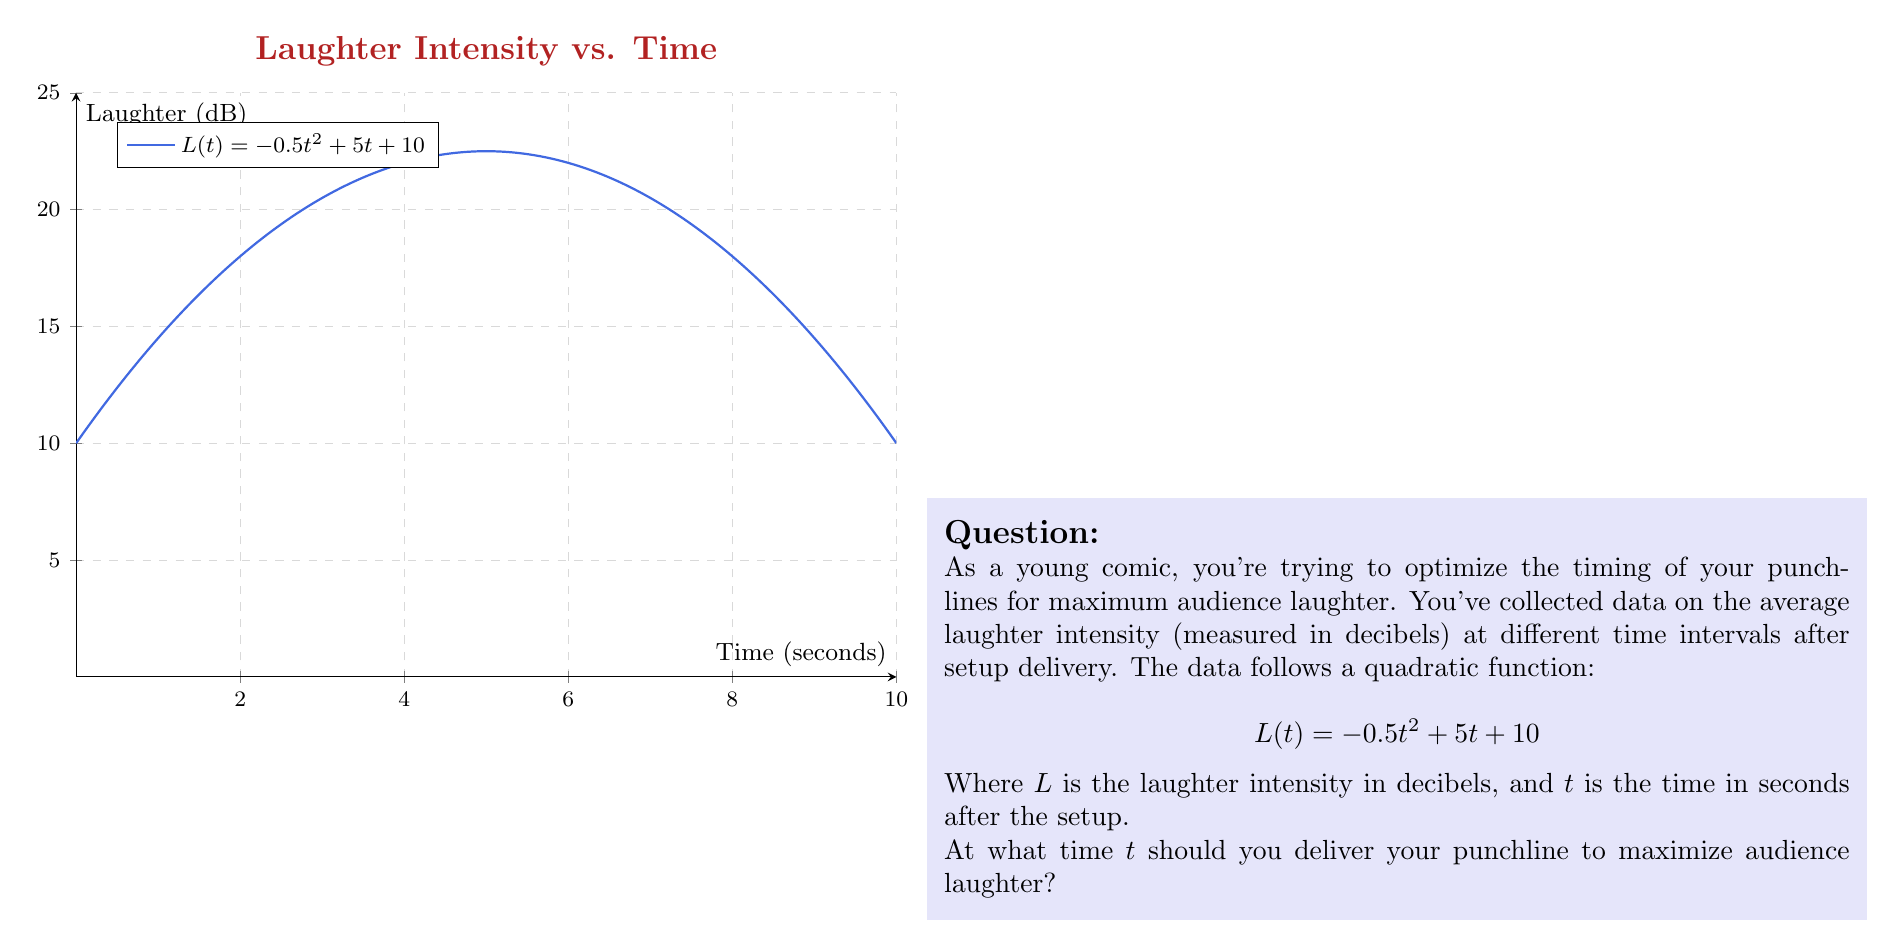Can you answer this question? To find the optimal time for delivering the punchline, we need to find the maximum point of the quadratic function $L(t) = -0.5t^2 + 5t + 10$. This can be done using the following steps:

1) The maximum point of a quadratic function occurs at the vertex of the parabola. For a quadratic function in the form $f(x) = ax^2 + bx + c$, the x-coordinate of the vertex is given by $x = -\frac{b}{2a}$.

2) In our case, $a = -0.5$, $b = 5$, and $c = 10$. Let's substitute these values:

   $$t = -\frac{5}{2(-0.5)} = -\frac{5}{-1} = 5$$

3) To verify this is indeed a maximum (not a minimum), we can check that $a < 0$, which it is ($-0.5 < 0$).

4) Therefore, the laughter intensity is maximized when $t = 5$ seconds.

5) We can calculate the maximum laughter intensity by substituting $t = 5$ into the original function:

   $$L(5) = -0.5(5)^2 + 5(5) + 10 = -12.5 + 25 + 10 = 22.5$$

So, the maximum laughter intensity is 22.5 decibels, occurring 5 seconds after the setup.
Answer: 5 seconds 